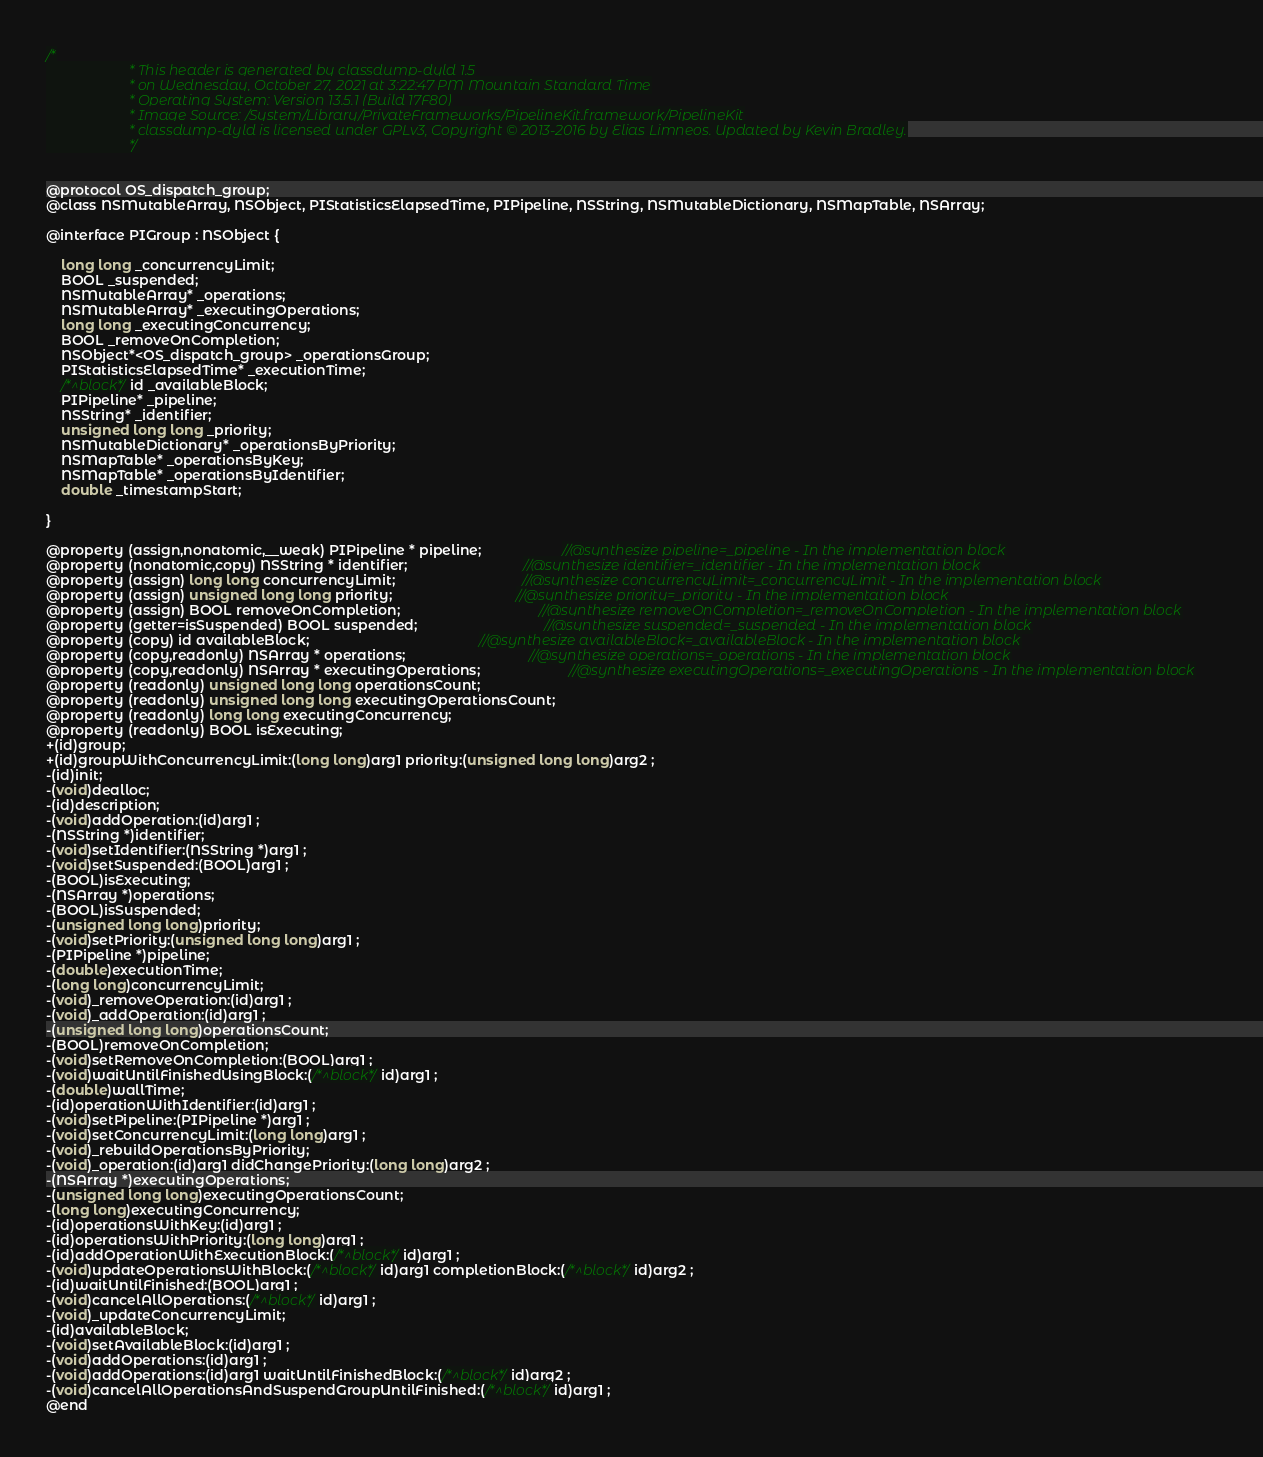<code> <loc_0><loc_0><loc_500><loc_500><_C_>/*
                       * This header is generated by classdump-dyld 1.5
                       * on Wednesday, October 27, 2021 at 3:22:47 PM Mountain Standard Time
                       * Operating System: Version 13.5.1 (Build 17F80)
                       * Image Source: /System/Library/PrivateFrameworks/PipelineKit.framework/PipelineKit
                       * classdump-dyld is licensed under GPLv3, Copyright © 2013-2016 by Elias Limneos. Updated by Kevin Bradley.
                       */


@protocol OS_dispatch_group;
@class NSMutableArray, NSObject, PIStatisticsElapsedTime, PIPipeline, NSString, NSMutableDictionary, NSMapTable, NSArray;

@interface PIGroup : NSObject {

	long long _concurrencyLimit;
	BOOL _suspended;
	NSMutableArray* _operations;
	NSMutableArray* _executingOperations;
	long long _executingConcurrency;
	BOOL _removeOnCompletion;
	NSObject*<OS_dispatch_group> _operationsGroup;
	PIStatisticsElapsedTime* _executionTime;
	/*^block*/id _availableBlock;
	PIPipeline* _pipeline;
	NSString* _identifier;
	unsigned long long _priority;
	NSMutableDictionary* _operationsByPriority;
	NSMapTable* _operationsByKey;
	NSMapTable* _operationsByIdentifier;
	double _timestampStart;

}

@property (assign,nonatomic,__weak) PIPipeline * pipeline;                     //@synthesize pipeline=_pipeline - In the implementation block
@property (nonatomic,copy) NSString * identifier;                              //@synthesize identifier=_identifier - In the implementation block
@property (assign) long long concurrencyLimit;                                 //@synthesize concurrencyLimit=_concurrencyLimit - In the implementation block
@property (assign) unsigned long long priority;                                //@synthesize priority=_priority - In the implementation block
@property (assign) BOOL removeOnCompletion;                                    //@synthesize removeOnCompletion=_removeOnCompletion - In the implementation block
@property (getter=isSuspended) BOOL suspended;                                 //@synthesize suspended=_suspended - In the implementation block
@property (copy) id availableBlock;                                            //@synthesize availableBlock=_availableBlock - In the implementation block
@property (copy,readonly) NSArray * operations;                                //@synthesize operations=_operations - In the implementation block
@property (copy,readonly) NSArray * executingOperations;                       //@synthesize executingOperations=_executingOperations - In the implementation block
@property (readonly) unsigned long long operationsCount; 
@property (readonly) unsigned long long executingOperationsCount; 
@property (readonly) long long executingConcurrency; 
@property (readonly) BOOL isExecuting; 
+(id)group;
+(id)groupWithConcurrencyLimit:(long long)arg1 priority:(unsigned long long)arg2 ;
-(id)init;
-(void)dealloc;
-(id)description;
-(void)addOperation:(id)arg1 ;
-(NSString *)identifier;
-(void)setIdentifier:(NSString *)arg1 ;
-(void)setSuspended:(BOOL)arg1 ;
-(BOOL)isExecuting;
-(NSArray *)operations;
-(BOOL)isSuspended;
-(unsigned long long)priority;
-(void)setPriority:(unsigned long long)arg1 ;
-(PIPipeline *)pipeline;
-(double)executionTime;
-(long long)concurrencyLimit;
-(void)_removeOperation:(id)arg1 ;
-(void)_addOperation:(id)arg1 ;
-(unsigned long long)operationsCount;
-(BOOL)removeOnCompletion;
-(void)setRemoveOnCompletion:(BOOL)arg1 ;
-(void)waitUntilFinishedUsingBlock:(/*^block*/id)arg1 ;
-(double)wallTime;
-(id)operationWithIdentifier:(id)arg1 ;
-(void)setPipeline:(PIPipeline *)arg1 ;
-(void)setConcurrencyLimit:(long long)arg1 ;
-(void)_rebuildOperationsByPriority;
-(void)_operation:(id)arg1 didChangePriority:(long long)arg2 ;
-(NSArray *)executingOperations;
-(unsigned long long)executingOperationsCount;
-(long long)executingConcurrency;
-(id)operationsWithKey:(id)arg1 ;
-(id)operationsWithPriority:(long long)arg1 ;
-(id)addOperationWithExecutionBlock:(/*^block*/id)arg1 ;
-(void)updateOperationsWithBlock:(/*^block*/id)arg1 completionBlock:(/*^block*/id)arg2 ;
-(id)waitUntilFinished:(BOOL)arg1 ;
-(void)cancelAllOperations:(/*^block*/id)arg1 ;
-(void)_updateConcurrencyLimit;
-(id)availableBlock;
-(void)setAvailableBlock:(id)arg1 ;
-(void)addOperations:(id)arg1 ;
-(void)addOperations:(id)arg1 waitUntilFinishedBlock:(/*^block*/id)arg2 ;
-(void)cancelAllOperationsAndSuspendGroupUntilFinished:(/*^block*/id)arg1 ;
@end

</code> 